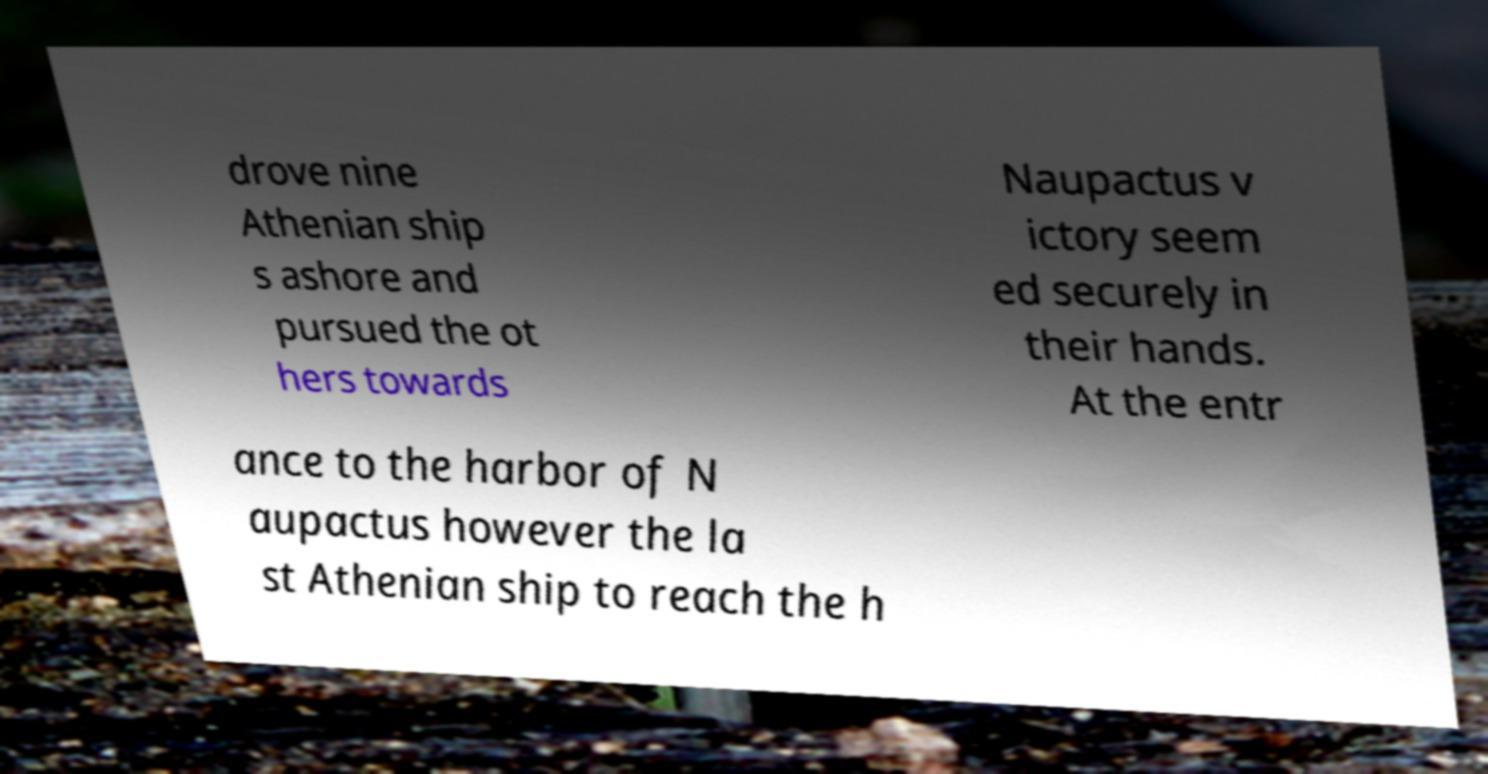I need the written content from this picture converted into text. Can you do that? drove nine Athenian ship s ashore and pursued the ot hers towards Naupactus v ictory seem ed securely in their hands. At the entr ance to the harbor of N aupactus however the la st Athenian ship to reach the h 